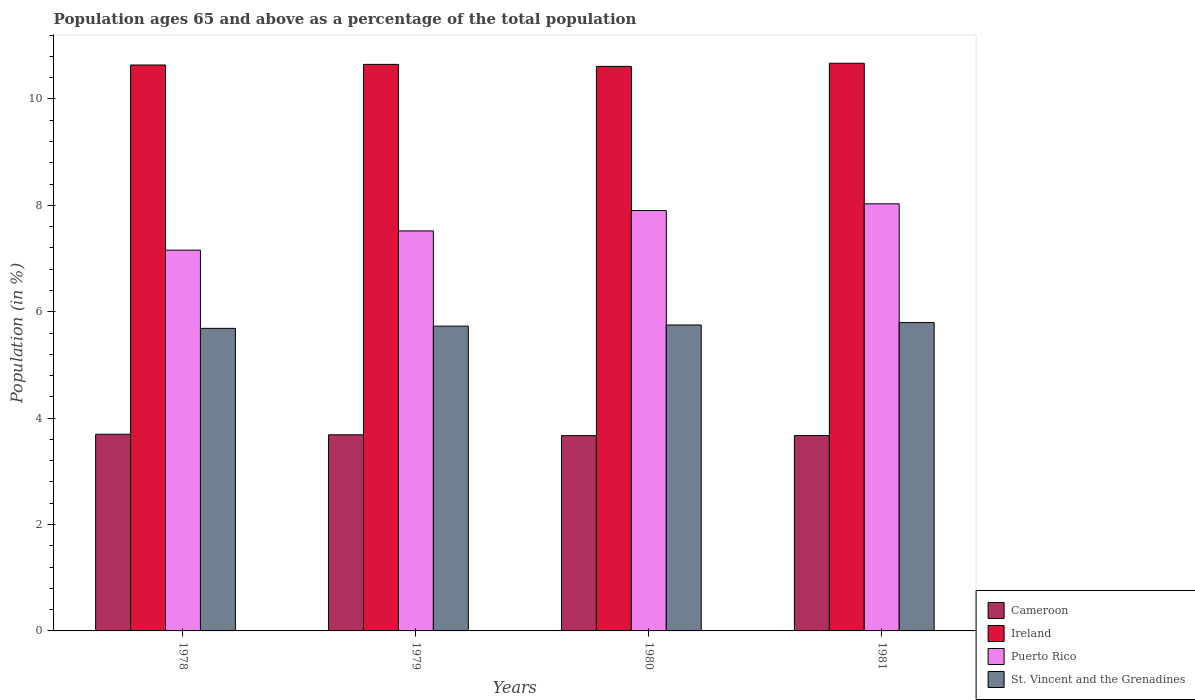How many groups of bars are there?
Your answer should be compact. 4. How many bars are there on the 1st tick from the right?
Provide a succinct answer. 4. What is the percentage of the population ages 65 and above in Ireland in 1978?
Keep it short and to the point. 10.64. Across all years, what is the maximum percentage of the population ages 65 and above in Puerto Rico?
Provide a short and direct response. 8.03. Across all years, what is the minimum percentage of the population ages 65 and above in Puerto Rico?
Keep it short and to the point. 7.16. What is the total percentage of the population ages 65 and above in Cameroon in the graph?
Provide a short and direct response. 14.73. What is the difference between the percentage of the population ages 65 and above in Puerto Rico in 1980 and that in 1981?
Make the answer very short. -0.13. What is the difference between the percentage of the population ages 65 and above in Puerto Rico in 1980 and the percentage of the population ages 65 and above in Ireland in 1979?
Give a very brief answer. -2.75. What is the average percentage of the population ages 65 and above in Puerto Rico per year?
Ensure brevity in your answer.  7.65. In the year 1980, what is the difference between the percentage of the population ages 65 and above in Ireland and percentage of the population ages 65 and above in St. Vincent and the Grenadines?
Your answer should be compact. 4.86. What is the ratio of the percentage of the population ages 65 and above in St. Vincent and the Grenadines in 1980 to that in 1981?
Give a very brief answer. 0.99. Is the percentage of the population ages 65 and above in Puerto Rico in 1978 less than that in 1981?
Keep it short and to the point. Yes. What is the difference between the highest and the second highest percentage of the population ages 65 and above in St. Vincent and the Grenadines?
Provide a short and direct response. 0.05. What is the difference between the highest and the lowest percentage of the population ages 65 and above in St. Vincent and the Grenadines?
Give a very brief answer. 0.11. In how many years, is the percentage of the population ages 65 and above in Cameroon greater than the average percentage of the population ages 65 and above in Cameroon taken over all years?
Provide a succinct answer. 2. Is the sum of the percentage of the population ages 65 and above in Puerto Rico in 1979 and 1980 greater than the maximum percentage of the population ages 65 and above in Cameroon across all years?
Keep it short and to the point. Yes. Is it the case that in every year, the sum of the percentage of the population ages 65 and above in Cameroon and percentage of the population ages 65 and above in Ireland is greater than the sum of percentage of the population ages 65 and above in St. Vincent and the Grenadines and percentage of the population ages 65 and above in Puerto Rico?
Your response must be concise. Yes. What does the 3rd bar from the left in 1980 represents?
Ensure brevity in your answer.  Puerto Rico. What does the 2nd bar from the right in 1979 represents?
Provide a succinct answer. Puerto Rico. Is it the case that in every year, the sum of the percentage of the population ages 65 and above in Puerto Rico and percentage of the population ages 65 and above in Cameroon is greater than the percentage of the population ages 65 and above in Ireland?
Offer a terse response. Yes. Are the values on the major ticks of Y-axis written in scientific E-notation?
Your answer should be compact. No. Does the graph contain grids?
Your answer should be compact. No. How are the legend labels stacked?
Keep it short and to the point. Vertical. What is the title of the graph?
Your answer should be compact. Population ages 65 and above as a percentage of the total population. Does "Chile" appear as one of the legend labels in the graph?
Your answer should be very brief. No. What is the label or title of the X-axis?
Ensure brevity in your answer.  Years. What is the Population (in %) in Cameroon in 1978?
Your response must be concise. 3.7. What is the Population (in %) of Ireland in 1978?
Provide a succinct answer. 10.64. What is the Population (in %) of Puerto Rico in 1978?
Give a very brief answer. 7.16. What is the Population (in %) of St. Vincent and the Grenadines in 1978?
Keep it short and to the point. 5.69. What is the Population (in %) of Cameroon in 1979?
Give a very brief answer. 3.69. What is the Population (in %) in Ireland in 1979?
Your answer should be very brief. 10.65. What is the Population (in %) in Puerto Rico in 1979?
Provide a short and direct response. 7.52. What is the Population (in %) in St. Vincent and the Grenadines in 1979?
Provide a short and direct response. 5.73. What is the Population (in %) of Cameroon in 1980?
Offer a terse response. 3.67. What is the Population (in %) in Ireland in 1980?
Give a very brief answer. 10.61. What is the Population (in %) in Puerto Rico in 1980?
Your response must be concise. 7.9. What is the Population (in %) of St. Vincent and the Grenadines in 1980?
Your answer should be compact. 5.75. What is the Population (in %) in Cameroon in 1981?
Provide a short and direct response. 3.67. What is the Population (in %) in Ireland in 1981?
Give a very brief answer. 10.67. What is the Population (in %) of Puerto Rico in 1981?
Ensure brevity in your answer.  8.03. What is the Population (in %) in St. Vincent and the Grenadines in 1981?
Ensure brevity in your answer.  5.8. Across all years, what is the maximum Population (in %) in Cameroon?
Ensure brevity in your answer.  3.7. Across all years, what is the maximum Population (in %) in Ireland?
Your answer should be compact. 10.67. Across all years, what is the maximum Population (in %) of Puerto Rico?
Give a very brief answer. 8.03. Across all years, what is the maximum Population (in %) in St. Vincent and the Grenadines?
Your response must be concise. 5.8. Across all years, what is the minimum Population (in %) of Cameroon?
Your answer should be very brief. 3.67. Across all years, what is the minimum Population (in %) of Ireland?
Make the answer very short. 10.61. Across all years, what is the minimum Population (in %) in Puerto Rico?
Offer a terse response. 7.16. Across all years, what is the minimum Population (in %) of St. Vincent and the Grenadines?
Keep it short and to the point. 5.69. What is the total Population (in %) of Cameroon in the graph?
Provide a succinct answer. 14.73. What is the total Population (in %) in Ireland in the graph?
Offer a very short reply. 42.57. What is the total Population (in %) of Puerto Rico in the graph?
Provide a short and direct response. 30.61. What is the total Population (in %) of St. Vincent and the Grenadines in the graph?
Provide a succinct answer. 22.96. What is the difference between the Population (in %) of Cameroon in 1978 and that in 1979?
Give a very brief answer. 0.01. What is the difference between the Population (in %) in Ireland in 1978 and that in 1979?
Offer a terse response. -0.01. What is the difference between the Population (in %) of Puerto Rico in 1978 and that in 1979?
Give a very brief answer. -0.36. What is the difference between the Population (in %) of St. Vincent and the Grenadines in 1978 and that in 1979?
Ensure brevity in your answer.  -0.04. What is the difference between the Population (in %) of Cameroon in 1978 and that in 1980?
Your answer should be compact. 0.03. What is the difference between the Population (in %) in Ireland in 1978 and that in 1980?
Ensure brevity in your answer.  0.03. What is the difference between the Population (in %) in Puerto Rico in 1978 and that in 1980?
Offer a terse response. -0.74. What is the difference between the Population (in %) of St. Vincent and the Grenadines in 1978 and that in 1980?
Ensure brevity in your answer.  -0.06. What is the difference between the Population (in %) of Cameroon in 1978 and that in 1981?
Provide a succinct answer. 0.02. What is the difference between the Population (in %) in Ireland in 1978 and that in 1981?
Provide a short and direct response. -0.03. What is the difference between the Population (in %) of Puerto Rico in 1978 and that in 1981?
Your answer should be very brief. -0.87. What is the difference between the Population (in %) of St. Vincent and the Grenadines in 1978 and that in 1981?
Offer a very short reply. -0.11. What is the difference between the Population (in %) in Cameroon in 1979 and that in 1980?
Your response must be concise. 0.02. What is the difference between the Population (in %) in Ireland in 1979 and that in 1980?
Your answer should be compact. 0.04. What is the difference between the Population (in %) in Puerto Rico in 1979 and that in 1980?
Give a very brief answer. -0.38. What is the difference between the Population (in %) of St. Vincent and the Grenadines in 1979 and that in 1980?
Your answer should be compact. -0.02. What is the difference between the Population (in %) in Cameroon in 1979 and that in 1981?
Provide a succinct answer. 0.01. What is the difference between the Population (in %) in Ireland in 1979 and that in 1981?
Ensure brevity in your answer.  -0.02. What is the difference between the Population (in %) of Puerto Rico in 1979 and that in 1981?
Give a very brief answer. -0.51. What is the difference between the Population (in %) of St. Vincent and the Grenadines in 1979 and that in 1981?
Offer a terse response. -0.07. What is the difference between the Population (in %) in Cameroon in 1980 and that in 1981?
Make the answer very short. -0. What is the difference between the Population (in %) of Ireland in 1980 and that in 1981?
Provide a succinct answer. -0.06. What is the difference between the Population (in %) of Puerto Rico in 1980 and that in 1981?
Provide a short and direct response. -0.13. What is the difference between the Population (in %) of St. Vincent and the Grenadines in 1980 and that in 1981?
Your answer should be compact. -0.05. What is the difference between the Population (in %) in Cameroon in 1978 and the Population (in %) in Ireland in 1979?
Keep it short and to the point. -6.95. What is the difference between the Population (in %) of Cameroon in 1978 and the Population (in %) of Puerto Rico in 1979?
Ensure brevity in your answer.  -3.82. What is the difference between the Population (in %) in Cameroon in 1978 and the Population (in %) in St. Vincent and the Grenadines in 1979?
Ensure brevity in your answer.  -2.03. What is the difference between the Population (in %) in Ireland in 1978 and the Population (in %) in Puerto Rico in 1979?
Your answer should be very brief. 3.12. What is the difference between the Population (in %) in Ireland in 1978 and the Population (in %) in St. Vincent and the Grenadines in 1979?
Offer a very short reply. 4.91. What is the difference between the Population (in %) in Puerto Rico in 1978 and the Population (in %) in St. Vincent and the Grenadines in 1979?
Keep it short and to the point. 1.43. What is the difference between the Population (in %) of Cameroon in 1978 and the Population (in %) of Ireland in 1980?
Offer a very short reply. -6.92. What is the difference between the Population (in %) of Cameroon in 1978 and the Population (in %) of Puerto Rico in 1980?
Your answer should be very brief. -4.21. What is the difference between the Population (in %) of Cameroon in 1978 and the Population (in %) of St. Vincent and the Grenadines in 1980?
Provide a short and direct response. -2.05. What is the difference between the Population (in %) of Ireland in 1978 and the Population (in %) of Puerto Rico in 1980?
Keep it short and to the point. 2.74. What is the difference between the Population (in %) in Ireland in 1978 and the Population (in %) in St. Vincent and the Grenadines in 1980?
Give a very brief answer. 4.89. What is the difference between the Population (in %) of Puerto Rico in 1978 and the Population (in %) of St. Vincent and the Grenadines in 1980?
Offer a very short reply. 1.41. What is the difference between the Population (in %) in Cameroon in 1978 and the Population (in %) in Ireland in 1981?
Provide a short and direct response. -6.97. What is the difference between the Population (in %) in Cameroon in 1978 and the Population (in %) in Puerto Rico in 1981?
Your answer should be compact. -4.33. What is the difference between the Population (in %) in Cameroon in 1978 and the Population (in %) in St. Vincent and the Grenadines in 1981?
Keep it short and to the point. -2.1. What is the difference between the Population (in %) of Ireland in 1978 and the Population (in %) of Puerto Rico in 1981?
Your answer should be very brief. 2.61. What is the difference between the Population (in %) of Ireland in 1978 and the Population (in %) of St. Vincent and the Grenadines in 1981?
Your response must be concise. 4.84. What is the difference between the Population (in %) in Puerto Rico in 1978 and the Population (in %) in St. Vincent and the Grenadines in 1981?
Ensure brevity in your answer.  1.36. What is the difference between the Population (in %) in Cameroon in 1979 and the Population (in %) in Ireland in 1980?
Make the answer very short. -6.93. What is the difference between the Population (in %) in Cameroon in 1979 and the Population (in %) in Puerto Rico in 1980?
Your answer should be compact. -4.22. What is the difference between the Population (in %) of Cameroon in 1979 and the Population (in %) of St. Vincent and the Grenadines in 1980?
Your answer should be very brief. -2.06. What is the difference between the Population (in %) in Ireland in 1979 and the Population (in %) in Puerto Rico in 1980?
Give a very brief answer. 2.75. What is the difference between the Population (in %) in Ireland in 1979 and the Population (in %) in St. Vincent and the Grenadines in 1980?
Provide a succinct answer. 4.9. What is the difference between the Population (in %) of Puerto Rico in 1979 and the Population (in %) of St. Vincent and the Grenadines in 1980?
Offer a very short reply. 1.77. What is the difference between the Population (in %) in Cameroon in 1979 and the Population (in %) in Ireland in 1981?
Your response must be concise. -6.98. What is the difference between the Population (in %) in Cameroon in 1979 and the Population (in %) in Puerto Rico in 1981?
Provide a short and direct response. -4.34. What is the difference between the Population (in %) of Cameroon in 1979 and the Population (in %) of St. Vincent and the Grenadines in 1981?
Offer a very short reply. -2.11. What is the difference between the Population (in %) of Ireland in 1979 and the Population (in %) of Puerto Rico in 1981?
Provide a succinct answer. 2.62. What is the difference between the Population (in %) of Ireland in 1979 and the Population (in %) of St. Vincent and the Grenadines in 1981?
Offer a terse response. 4.85. What is the difference between the Population (in %) of Puerto Rico in 1979 and the Population (in %) of St. Vincent and the Grenadines in 1981?
Offer a very short reply. 1.72. What is the difference between the Population (in %) in Cameroon in 1980 and the Population (in %) in Ireland in 1981?
Provide a succinct answer. -7. What is the difference between the Population (in %) of Cameroon in 1980 and the Population (in %) of Puerto Rico in 1981?
Offer a very short reply. -4.36. What is the difference between the Population (in %) in Cameroon in 1980 and the Population (in %) in St. Vincent and the Grenadines in 1981?
Your response must be concise. -2.12. What is the difference between the Population (in %) of Ireland in 1980 and the Population (in %) of Puerto Rico in 1981?
Your answer should be very brief. 2.58. What is the difference between the Population (in %) of Ireland in 1980 and the Population (in %) of St. Vincent and the Grenadines in 1981?
Provide a short and direct response. 4.82. What is the difference between the Population (in %) of Puerto Rico in 1980 and the Population (in %) of St. Vincent and the Grenadines in 1981?
Offer a terse response. 2.11. What is the average Population (in %) in Cameroon per year?
Provide a succinct answer. 3.68. What is the average Population (in %) in Ireland per year?
Give a very brief answer. 10.64. What is the average Population (in %) of Puerto Rico per year?
Your answer should be very brief. 7.65. What is the average Population (in %) in St. Vincent and the Grenadines per year?
Ensure brevity in your answer.  5.74. In the year 1978, what is the difference between the Population (in %) in Cameroon and Population (in %) in Ireland?
Provide a short and direct response. -6.94. In the year 1978, what is the difference between the Population (in %) of Cameroon and Population (in %) of Puerto Rico?
Your answer should be very brief. -3.46. In the year 1978, what is the difference between the Population (in %) of Cameroon and Population (in %) of St. Vincent and the Grenadines?
Your answer should be very brief. -1.99. In the year 1978, what is the difference between the Population (in %) of Ireland and Population (in %) of Puerto Rico?
Your response must be concise. 3.48. In the year 1978, what is the difference between the Population (in %) in Ireland and Population (in %) in St. Vincent and the Grenadines?
Your response must be concise. 4.95. In the year 1978, what is the difference between the Population (in %) in Puerto Rico and Population (in %) in St. Vincent and the Grenadines?
Your answer should be compact. 1.47. In the year 1979, what is the difference between the Population (in %) in Cameroon and Population (in %) in Ireland?
Your answer should be very brief. -6.96. In the year 1979, what is the difference between the Population (in %) in Cameroon and Population (in %) in Puerto Rico?
Your answer should be compact. -3.83. In the year 1979, what is the difference between the Population (in %) of Cameroon and Population (in %) of St. Vincent and the Grenadines?
Provide a short and direct response. -2.04. In the year 1979, what is the difference between the Population (in %) of Ireland and Population (in %) of Puerto Rico?
Offer a terse response. 3.13. In the year 1979, what is the difference between the Population (in %) in Ireland and Population (in %) in St. Vincent and the Grenadines?
Your answer should be compact. 4.92. In the year 1979, what is the difference between the Population (in %) of Puerto Rico and Population (in %) of St. Vincent and the Grenadines?
Your answer should be very brief. 1.79. In the year 1980, what is the difference between the Population (in %) of Cameroon and Population (in %) of Ireland?
Keep it short and to the point. -6.94. In the year 1980, what is the difference between the Population (in %) of Cameroon and Population (in %) of Puerto Rico?
Your answer should be very brief. -4.23. In the year 1980, what is the difference between the Population (in %) in Cameroon and Population (in %) in St. Vincent and the Grenadines?
Make the answer very short. -2.08. In the year 1980, what is the difference between the Population (in %) in Ireland and Population (in %) in Puerto Rico?
Your answer should be very brief. 2.71. In the year 1980, what is the difference between the Population (in %) in Ireland and Population (in %) in St. Vincent and the Grenadines?
Make the answer very short. 4.86. In the year 1980, what is the difference between the Population (in %) of Puerto Rico and Population (in %) of St. Vincent and the Grenadines?
Provide a succinct answer. 2.15. In the year 1981, what is the difference between the Population (in %) of Cameroon and Population (in %) of Ireland?
Keep it short and to the point. -7. In the year 1981, what is the difference between the Population (in %) of Cameroon and Population (in %) of Puerto Rico?
Make the answer very short. -4.36. In the year 1981, what is the difference between the Population (in %) in Cameroon and Population (in %) in St. Vincent and the Grenadines?
Give a very brief answer. -2.12. In the year 1981, what is the difference between the Population (in %) in Ireland and Population (in %) in Puerto Rico?
Your response must be concise. 2.64. In the year 1981, what is the difference between the Population (in %) of Ireland and Population (in %) of St. Vincent and the Grenadines?
Provide a succinct answer. 4.87. In the year 1981, what is the difference between the Population (in %) in Puerto Rico and Population (in %) in St. Vincent and the Grenadines?
Offer a very short reply. 2.23. What is the ratio of the Population (in %) of Ireland in 1978 to that in 1979?
Give a very brief answer. 1. What is the ratio of the Population (in %) of Puerto Rico in 1978 to that in 1979?
Keep it short and to the point. 0.95. What is the ratio of the Population (in %) in Cameroon in 1978 to that in 1980?
Provide a short and direct response. 1.01. What is the ratio of the Population (in %) of Ireland in 1978 to that in 1980?
Give a very brief answer. 1. What is the ratio of the Population (in %) of Puerto Rico in 1978 to that in 1980?
Your response must be concise. 0.91. What is the ratio of the Population (in %) in Ireland in 1978 to that in 1981?
Offer a very short reply. 1. What is the ratio of the Population (in %) in Puerto Rico in 1978 to that in 1981?
Provide a short and direct response. 0.89. What is the ratio of the Population (in %) of St. Vincent and the Grenadines in 1978 to that in 1981?
Offer a very short reply. 0.98. What is the ratio of the Population (in %) in Ireland in 1979 to that in 1980?
Offer a very short reply. 1. What is the ratio of the Population (in %) in Puerto Rico in 1979 to that in 1980?
Offer a very short reply. 0.95. What is the ratio of the Population (in %) of St. Vincent and the Grenadines in 1979 to that in 1980?
Make the answer very short. 1. What is the ratio of the Population (in %) of Ireland in 1979 to that in 1981?
Your answer should be very brief. 1. What is the ratio of the Population (in %) in Puerto Rico in 1979 to that in 1981?
Your answer should be very brief. 0.94. What is the ratio of the Population (in %) in Cameroon in 1980 to that in 1981?
Ensure brevity in your answer.  1. What is the ratio of the Population (in %) in Ireland in 1980 to that in 1981?
Your response must be concise. 0.99. What is the ratio of the Population (in %) of Puerto Rico in 1980 to that in 1981?
Make the answer very short. 0.98. What is the difference between the highest and the second highest Population (in %) of Cameroon?
Make the answer very short. 0.01. What is the difference between the highest and the second highest Population (in %) in Ireland?
Give a very brief answer. 0.02. What is the difference between the highest and the second highest Population (in %) in Puerto Rico?
Your answer should be compact. 0.13. What is the difference between the highest and the second highest Population (in %) in St. Vincent and the Grenadines?
Offer a very short reply. 0.05. What is the difference between the highest and the lowest Population (in %) of Cameroon?
Offer a terse response. 0.03. What is the difference between the highest and the lowest Population (in %) of Ireland?
Provide a succinct answer. 0.06. What is the difference between the highest and the lowest Population (in %) in Puerto Rico?
Your answer should be very brief. 0.87. What is the difference between the highest and the lowest Population (in %) of St. Vincent and the Grenadines?
Make the answer very short. 0.11. 